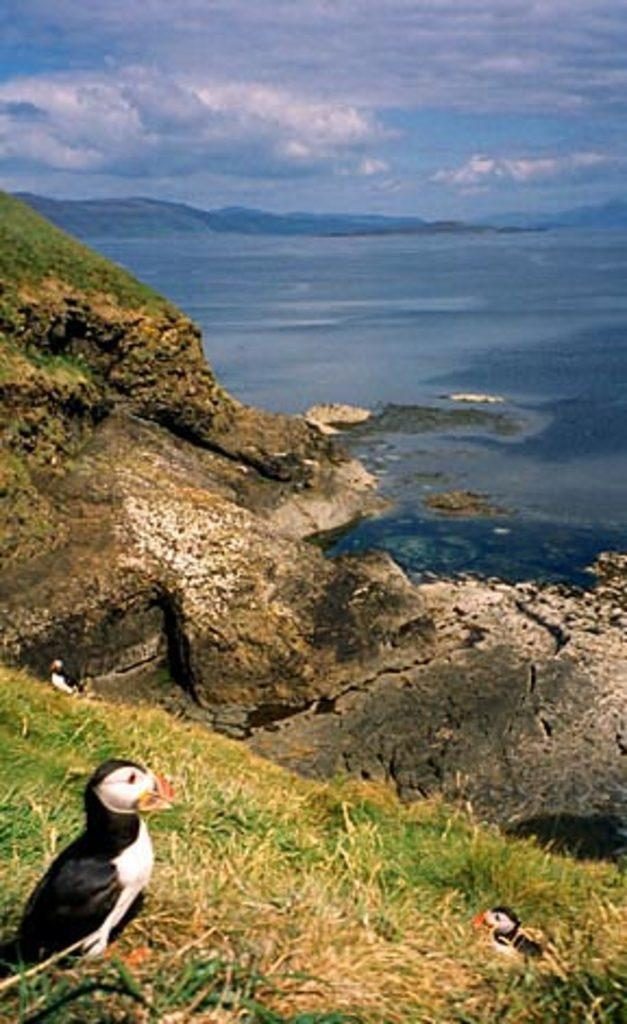What animals can be seen on the ground in the image? There are two birds on the ground in the image. What type of vegetation is visible in the image? There is grass and plants visible in the image. What type of landscape can be seen in the background of the image? There are mountains visible in the image. What natural feature can be seen near the birds? There is water visible in the image. What is visible in the sky in the image? The sky is visible in the image, and clouds are present. What type of account is being discussed in the meeting near the water? There is no meeting or account present in the image; it features two birds on the ground, grass, plants, mountains, water, and a sky with clouds. 